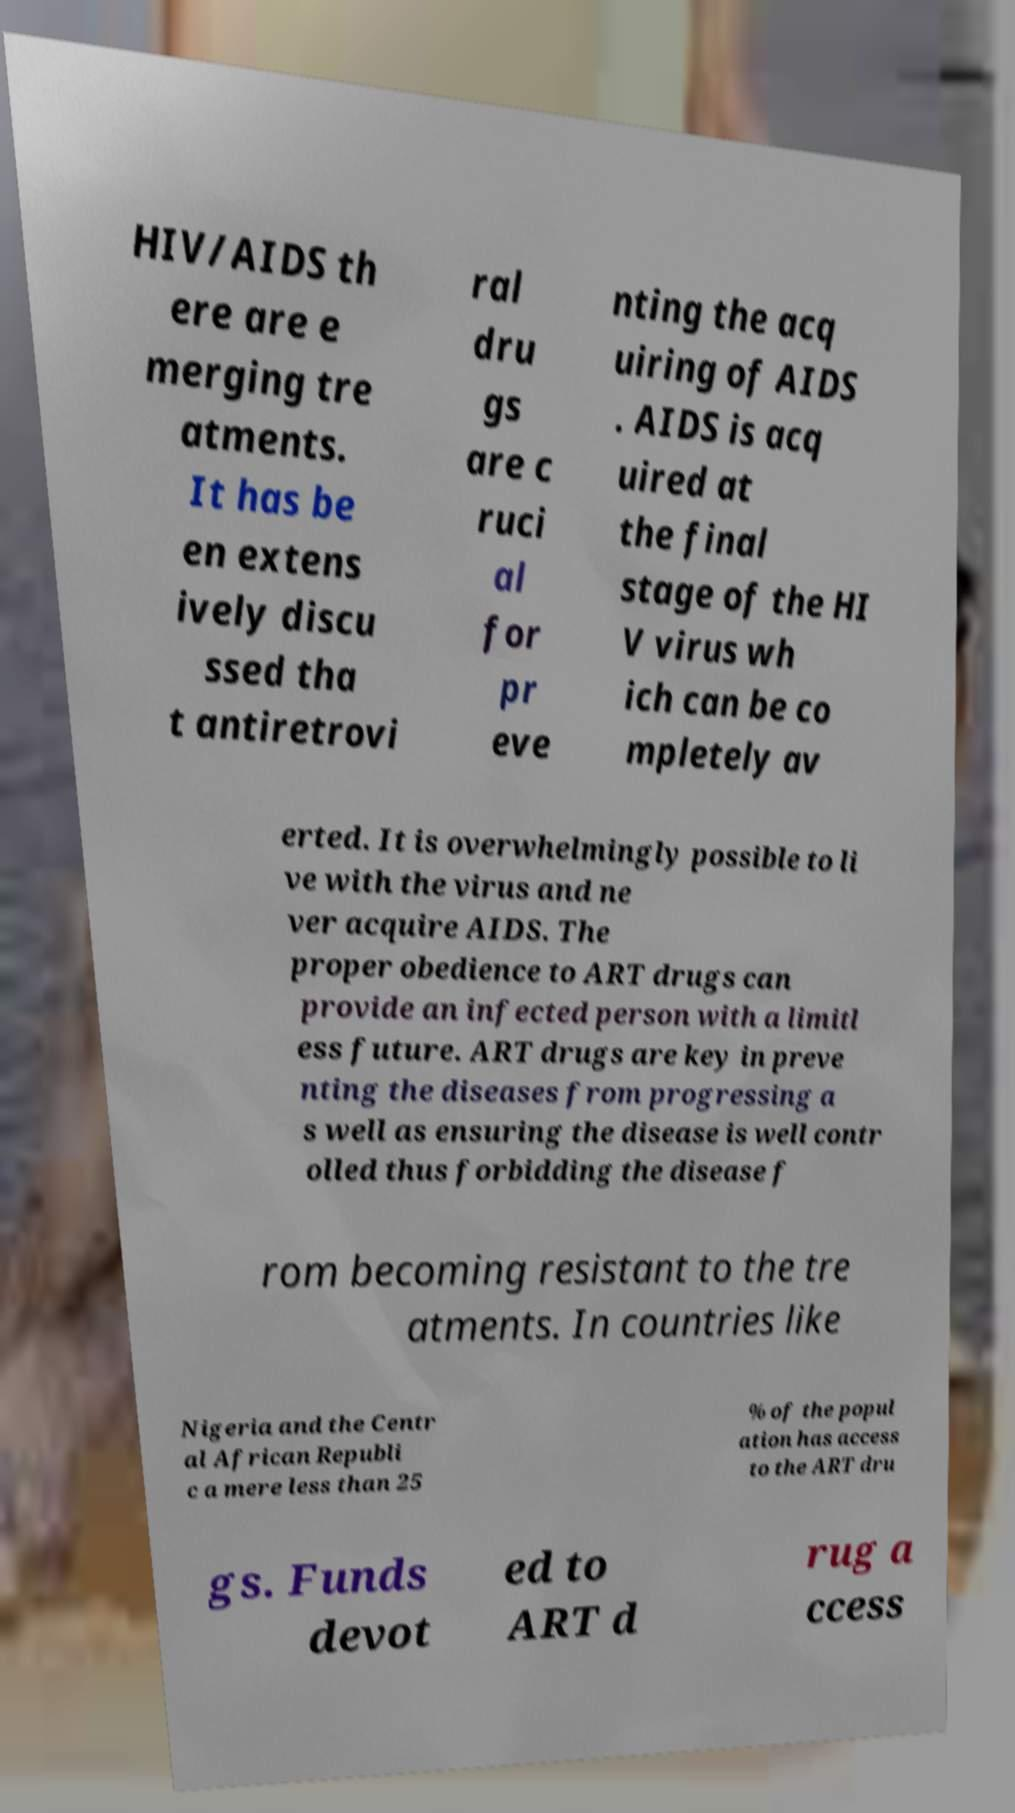What messages or text are displayed in this image? I need them in a readable, typed format. HIV/AIDS th ere are e merging tre atments. It has be en extens ively discu ssed tha t antiretrovi ral dru gs are c ruci al for pr eve nting the acq uiring of AIDS . AIDS is acq uired at the final stage of the HI V virus wh ich can be co mpletely av erted. It is overwhelmingly possible to li ve with the virus and ne ver acquire AIDS. The proper obedience to ART drugs can provide an infected person with a limitl ess future. ART drugs are key in preve nting the diseases from progressing a s well as ensuring the disease is well contr olled thus forbidding the disease f rom becoming resistant to the tre atments. In countries like Nigeria and the Centr al African Republi c a mere less than 25 % of the popul ation has access to the ART dru gs. Funds devot ed to ART d rug a ccess 